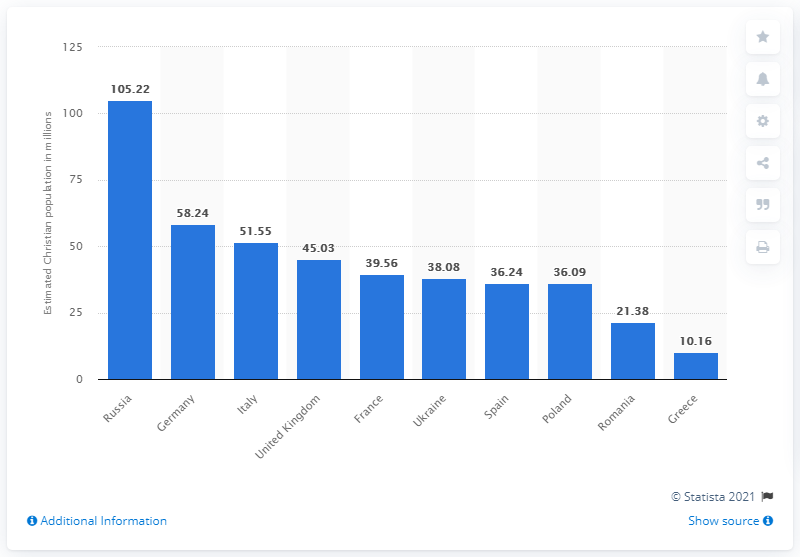Highlight a few significant elements in this photo. In 2010, it is estimated that there were approximately 105.22 million Christians living in Russia. 